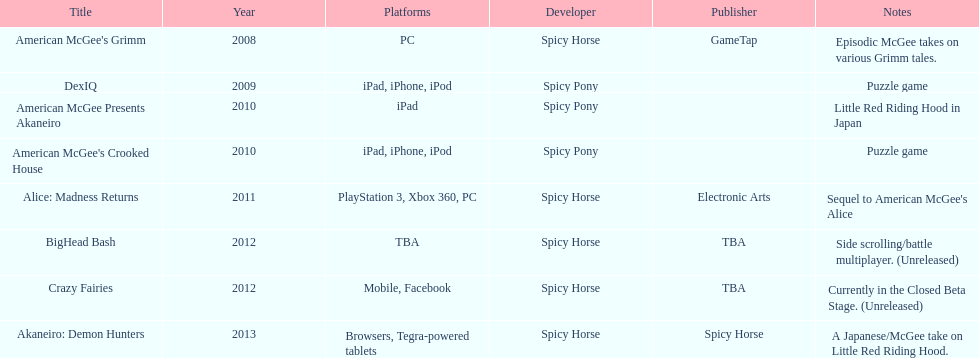Would you mind parsing the complete table? {'header': ['Title', 'Year', 'Platforms', 'Developer', 'Publisher', 'Notes'], 'rows': [["American McGee's Grimm", '2008', 'PC', 'Spicy Horse', 'GameTap', 'Episodic McGee takes on various Grimm tales.'], ['DexIQ', '2009', 'iPad, iPhone, iPod', 'Spicy Pony', '', 'Puzzle game'], ['American McGee Presents Akaneiro', '2010', 'iPad', 'Spicy Pony', '', 'Little Red Riding Hood in Japan'], ["American McGee's Crooked House", '2010', 'iPad, iPhone, iPod', 'Spicy Pony', '', 'Puzzle game'], ['Alice: Madness Returns', '2011', 'PlayStation 3, Xbox 360, PC', 'Spicy Horse', 'Electronic Arts', "Sequel to American McGee's Alice"], ['BigHead Bash', '2012', 'TBA', 'Spicy Horse', 'TBA', 'Side scrolling/battle multiplayer. (Unreleased)'], ['Crazy Fairies', '2012', 'Mobile, Facebook', 'Spicy Horse', 'TBA', 'Currently in the Closed Beta Stage. (Unreleased)'], ['Akaneiro: Demon Hunters', '2013', 'Browsers, Tegra-powered tablets', 'Spicy Horse', 'Spicy Horse', 'A Japanese/McGee take on Little Red Riding Hood.']]} What year had a total of 2 titles released? 2010. 